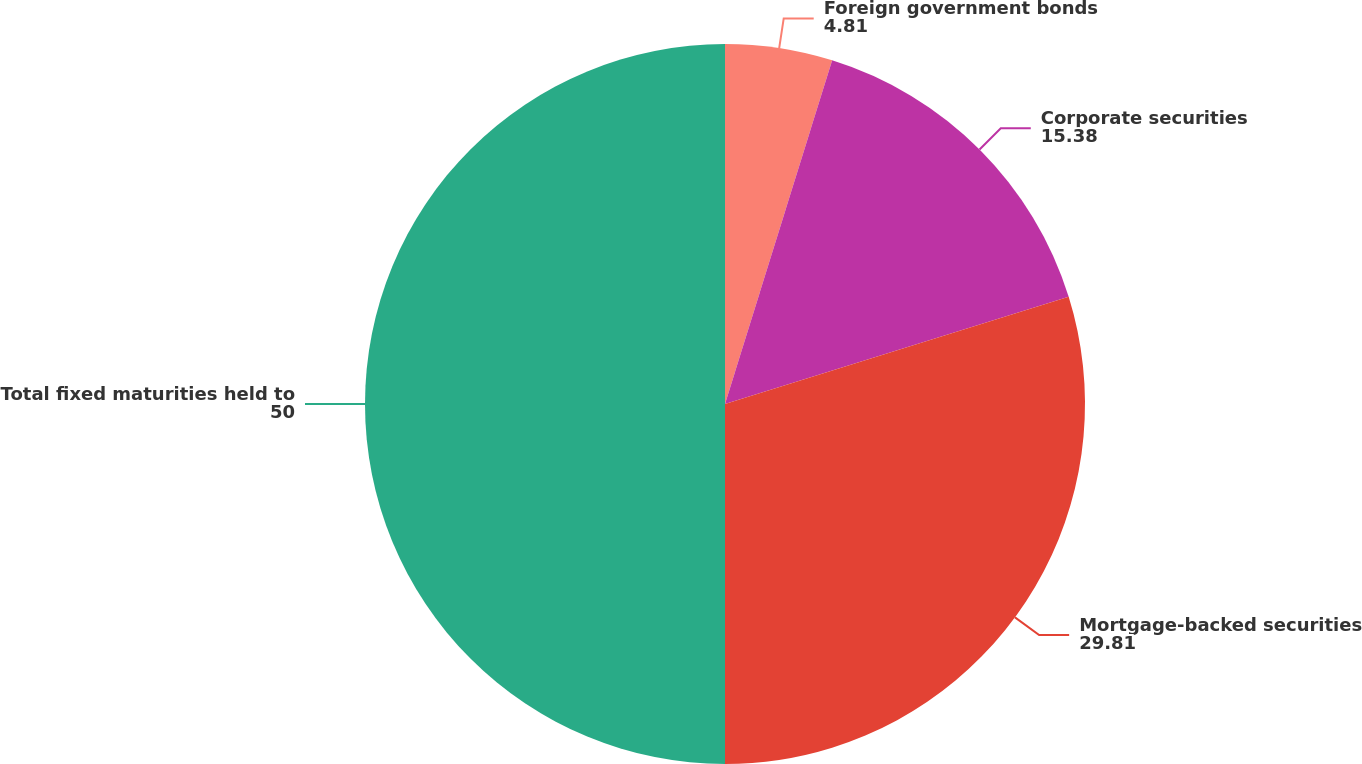Convert chart. <chart><loc_0><loc_0><loc_500><loc_500><pie_chart><fcel>Foreign government bonds<fcel>Corporate securities<fcel>Mortgage-backed securities<fcel>Total fixed maturities held to<nl><fcel>4.81%<fcel>15.38%<fcel>29.81%<fcel>50.0%<nl></chart> 